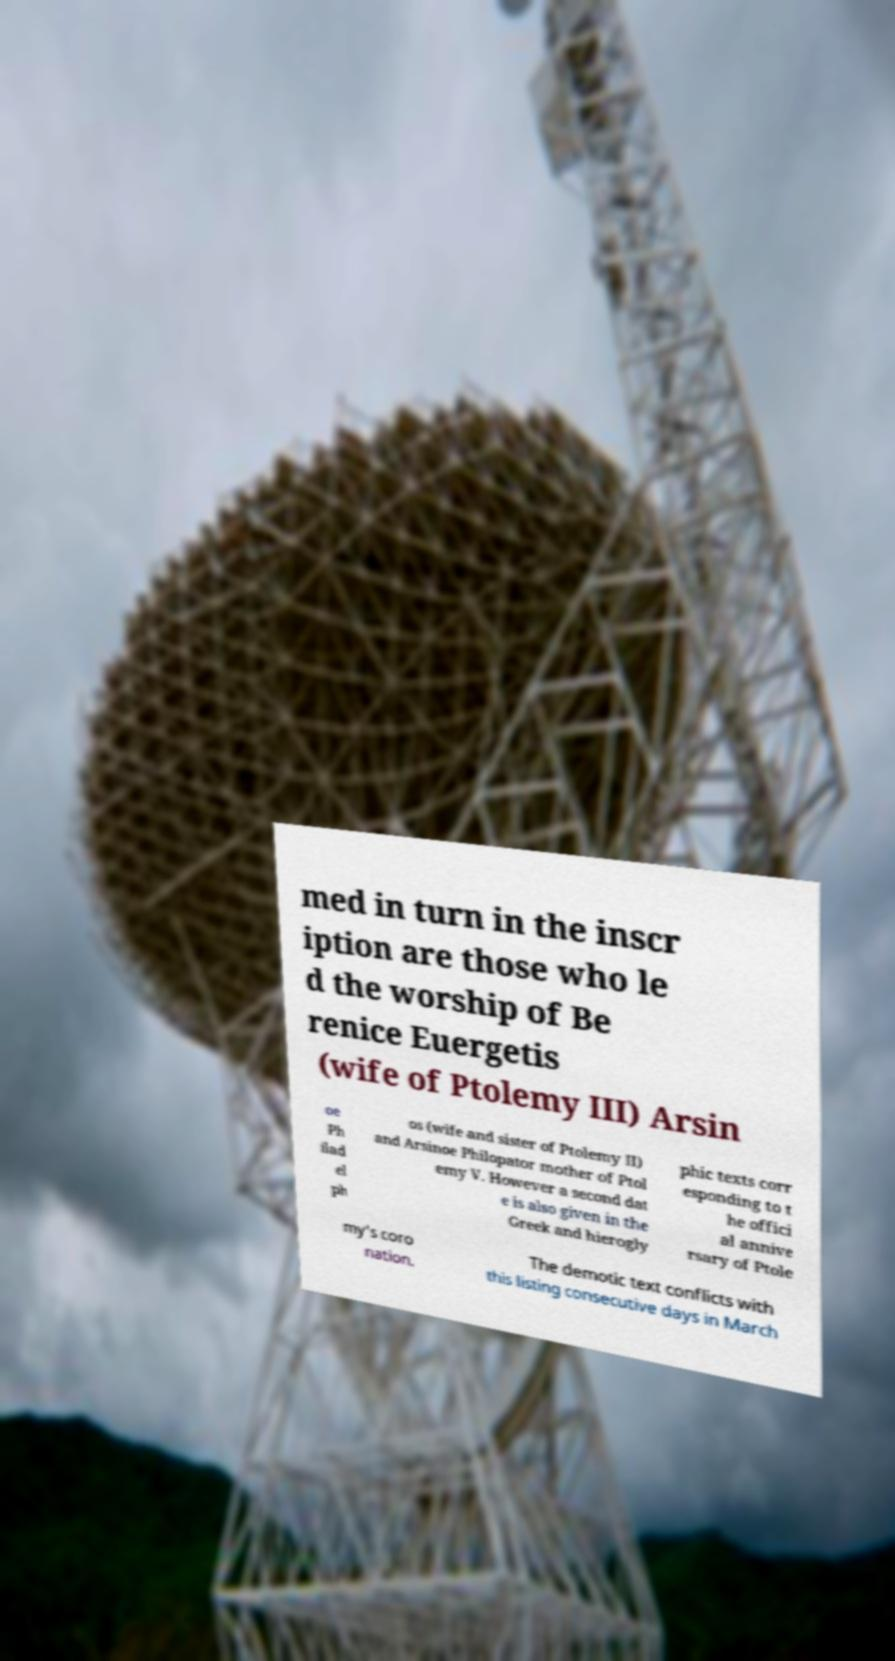I need the written content from this picture converted into text. Can you do that? med in turn in the inscr iption are those who le d the worship of Be renice Euergetis (wife of Ptolemy III) Arsin oe Ph ilad el ph os (wife and sister of Ptolemy II) and Arsinoe Philopator mother of Ptol emy V. However a second dat e is also given in the Greek and hierogly phic texts corr esponding to t he offici al annive rsary of Ptole my's coro nation. The demotic text conflicts with this listing consecutive days in March 